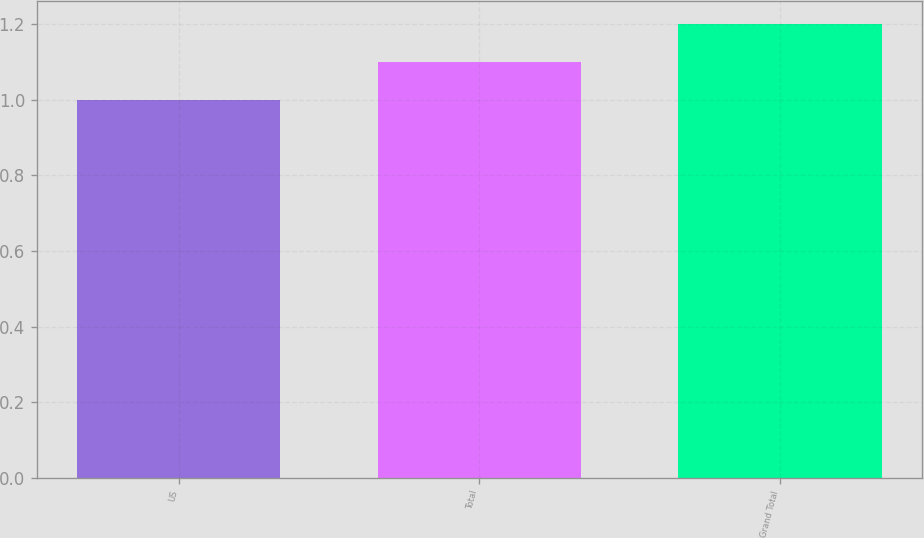Convert chart. <chart><loc_0><loc_0><loc_500><loc_500><bar_chart><fcel>US<fcel>Total<fcel>Grand Total<nl><fcel>1<fcel>1.1<fcel>1.2<nl></chart> 